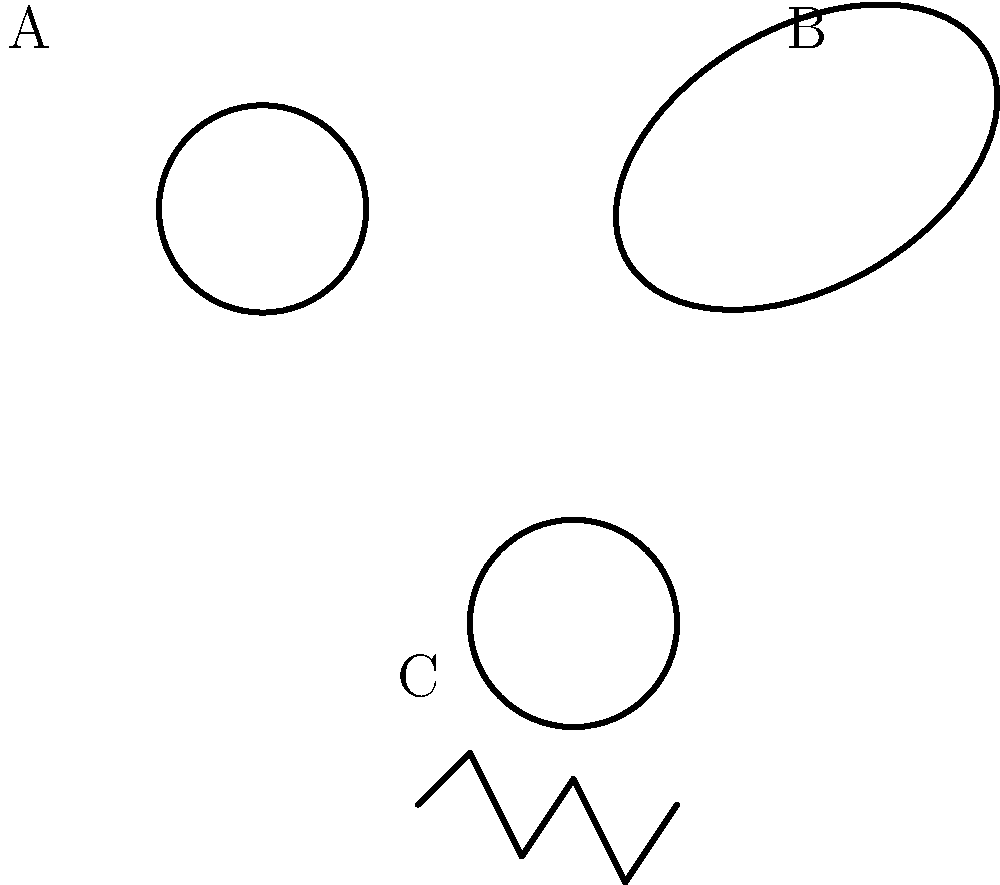As a media organization creating educational content on astronomy, you want to ensure accurate representation of galaxy types. The image above shows three different galaxy shapes labeled A, B, and C. Which of these represents an elliptical galaxy, and what are its key characteristics that distinguish it from the other types? Let's analyze each galaxy shape in the image:

1. Galaxy A: This shape shows spiral arms emanating from a central core, characteristic of a spiral galaxy. Spiral galaxies have distinct arms of stars, gas, and dust rotating around a central bulge.

2. Galaxy B: This shape is oval or elliptical, without any visible structure like arms or irregularities. This represents an elliptical galaxy.

3. Galaxy C: This shape is irregular and lacks a defined structure, typical of an irregular galaxy.

Key characteristics of elliptical galaxies (B):

1. Shape: They have a smooth, featureless appearance with an elliptical or oval shape.
2. Composition: Elliptical galaxies are primarily composed of older, redder stars with little gas or dust for new star formation.
3. Size variation: They can range from dwarf ellipticals to giant ellipticals, much larger than spiral galaxies.
4. Lack of structure: Unlike spiral galaxies, they don't have arms or distinct features.
5. Formation: They are thought to form through mergers of smaller galaxies, explaining their lack of gas and dust.

In creating media content, it's important to accurately represent these characteristics to educate the audience about the diversity of galaxy types and their formation processes.
Answer: B (elliptical galaxy); smooth elliptical shape, composed of older stars, lacks spiral arms or irregular structure. 